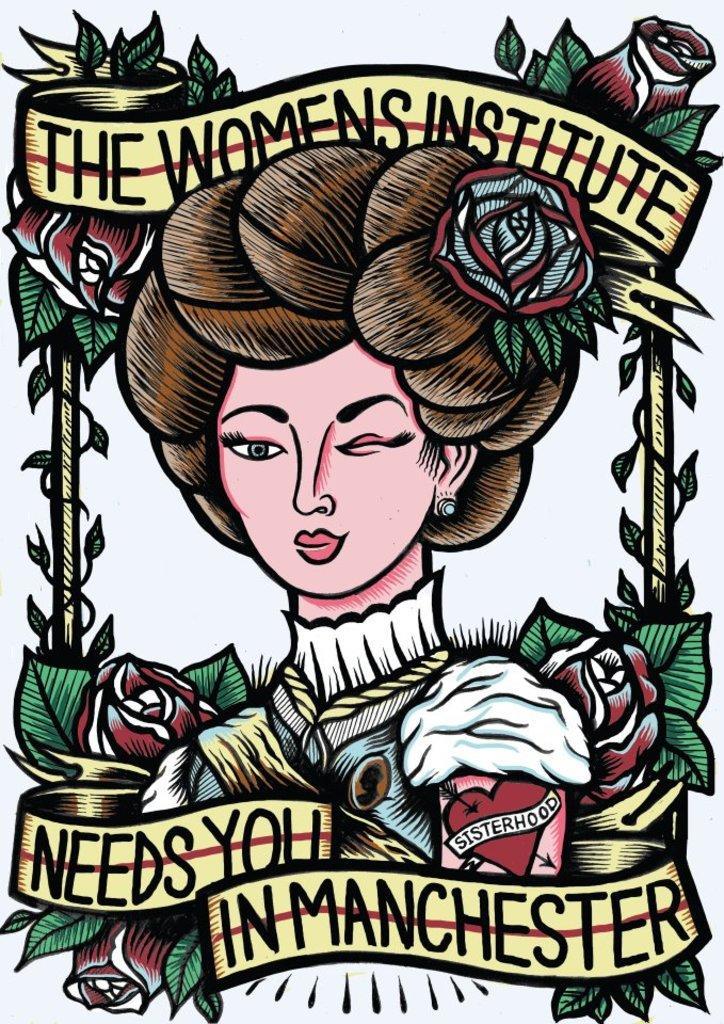In one or two sentences, can you explain what this image depicts? In the picture I can see the painting of a woman. I can see the flowers. There is a text at the top and at the bottom of the picture. 